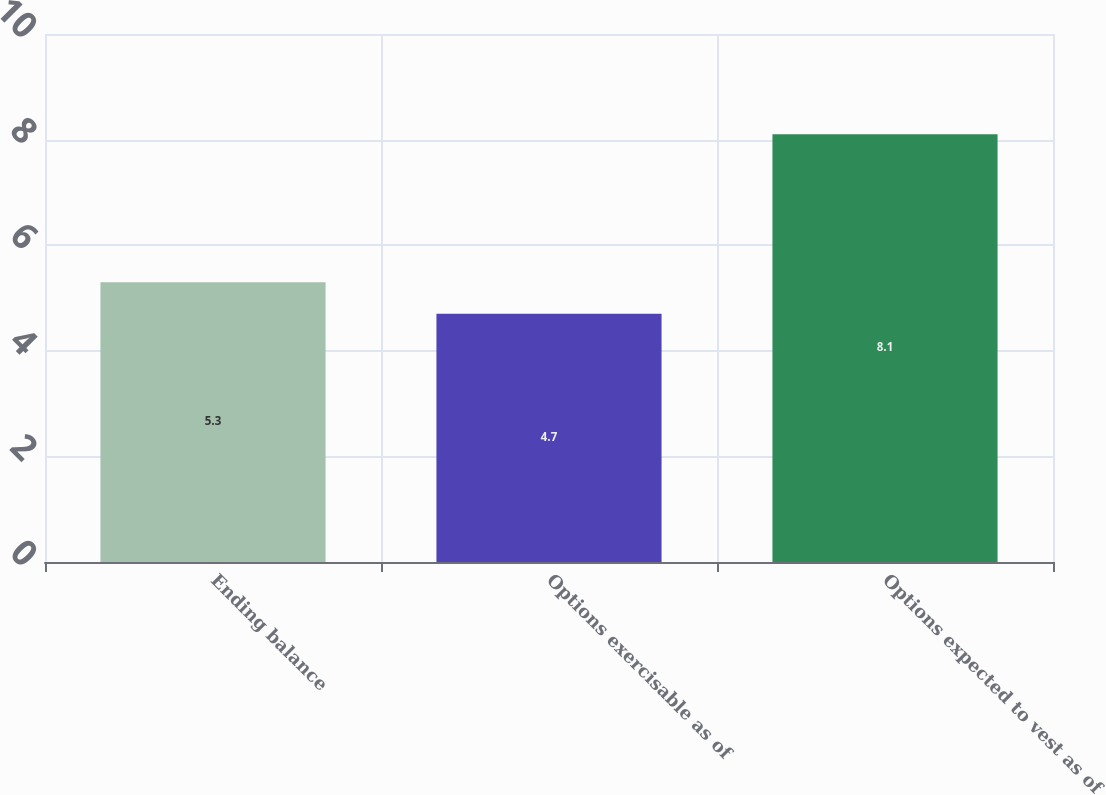<chart> <loc_0><loc_0><loc_500><loc_500><bar_chart><fcel>Ending balance<fcel>Options exercisable as of<fcel>Options expected to vest as of<nl><fcel>5.3<fcel>4.7<fcel>8.1<nl></chart> 